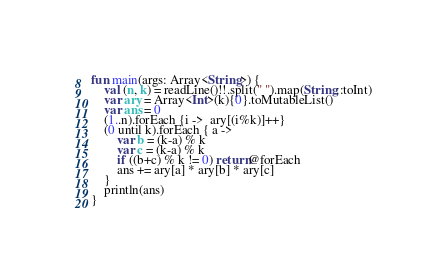Convert code to text. <code><loc_0><loc_0><loc_500><loc_500><_Kotlin_>
fun main(args: Array<String>) {
    val (n, k) = readLine()!!.split(" ").map(String::toInt)
    var ary = Array<Int>(k){0}.toMutableList()
    var ans = 0
    (1..n).forEach {i ->  ary[(i%k)]++}
    (0 until k).forEach { a ->
        var b = (k-a) % k
        var c = (k-a) % k
        if ((b+c) % k != 0) return@forEach
        ans += ary[a] * ary[b] * ary[c]
    }
    println(ans)
}</code> 